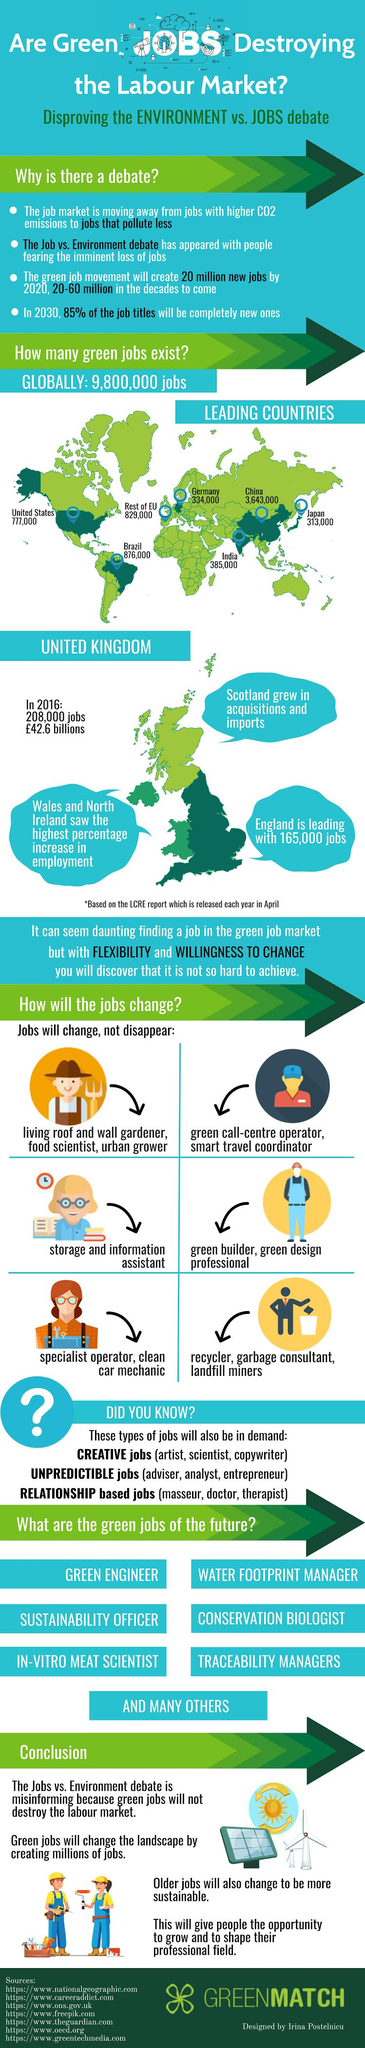Draw attention to some important aspects in this diagram. According to the LCRE report, England has the largest number of green jobs in the United Kingdom. According to a recent survey, there are approximately 385,000 green jobs available in India. There are approximately 313,000 green jobs available in Japan. 